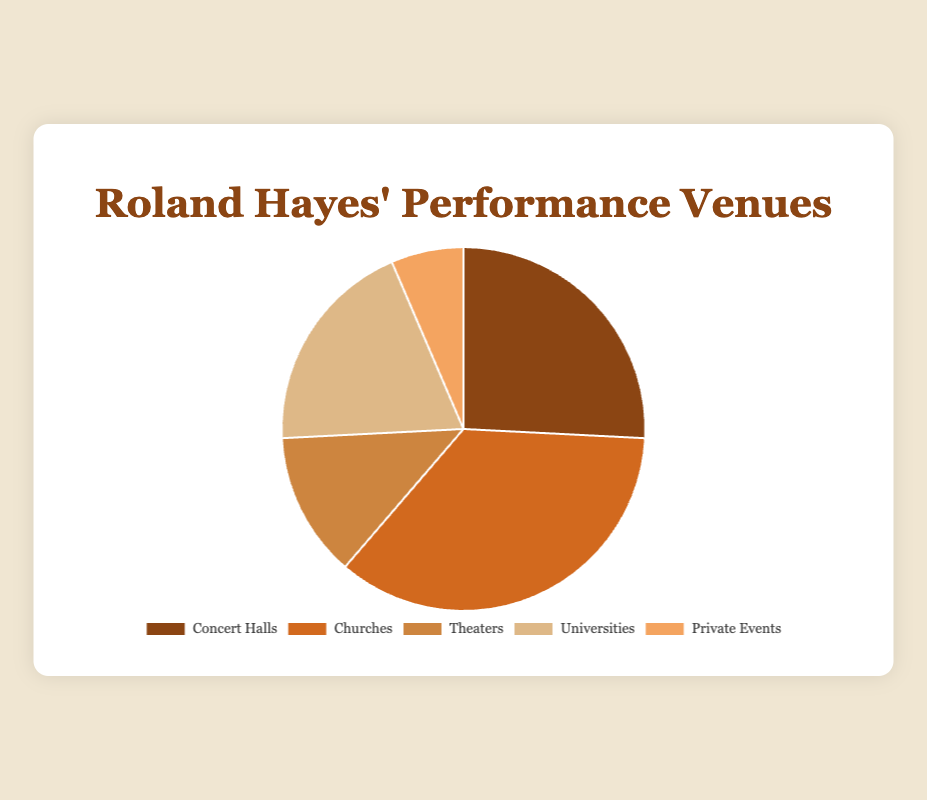Which venue type did Roland Hayes perform at the most? According to the pie chart, Roland Hayes performed at churches most frequently with a total of 55 performances.
Answer: Churches Which venue type had the fewest performances by Roland Hayes? The pie chart shows that the venue type with the fewest performances by Roland Hayes is private events, with a total of 10 performances.
Answer: Private Events How many more performances did Roland Hayes have in churches compared to theaters? Roland Hayes performed in churches 55 times and in theaters 20 times. The difference is 55 - 20 = 35.
Answer: 35 If you combine the performances at concert halls and universities, how many performances did Roland Hayes give in total at these venues? Roland Hayes performed 40 times in concert halls and 30 times in universities. Combined, this gives 40 + 30 = 70 performances.
Answer: 70 Which venue type has a darker color shade in the pie chart? The pie chart indicates that concert halls have the darkest color shade among all segments.
Answer: Concert Halls What percentage of Roland Hayes' performances were conducted in universities? The pie chart represents the total distribution. To find the percentage for universities: (performances at universities / total performances) * 100 = (30 / (40+55+20+30+10)) * 100 = (30 / 155) * 100 ≈ 19.35%.
Answer: Approximately 19.35% Which two venue types together make up less than half of Roland Hayes' total performances? The total performances are 155. Concert Halls (40) and Theaters (20) together make up 60 performances. 60/155 < 0.5. Hence, concert halls and theaters together make up less than half.
Answer: Concert Halls and Theaters Compare the number of performances at concert halls and private events. Which is higher and by how much? Roland Hayes performed 40 times in concert halls and 10 times at private events. The difference is 40 - 10 = 30, so he performed 30 more times in concert halls.
Answer: Concert Halls by 30 What fraction of performances did Roland Hayes give at churches compared to the total number of performances? The total number of performances is 155. The fraction for performances at churches is 55/155, which simplifies to 11/31.
Answer: 11/31 What is the average number of performances per venue type? To find the average, sum the total performances and divide by the number of venue types: (40 + 55 + 20 + 30 + 10) / 5 = 155 / 5 = 31.
Answer: 31 performances 